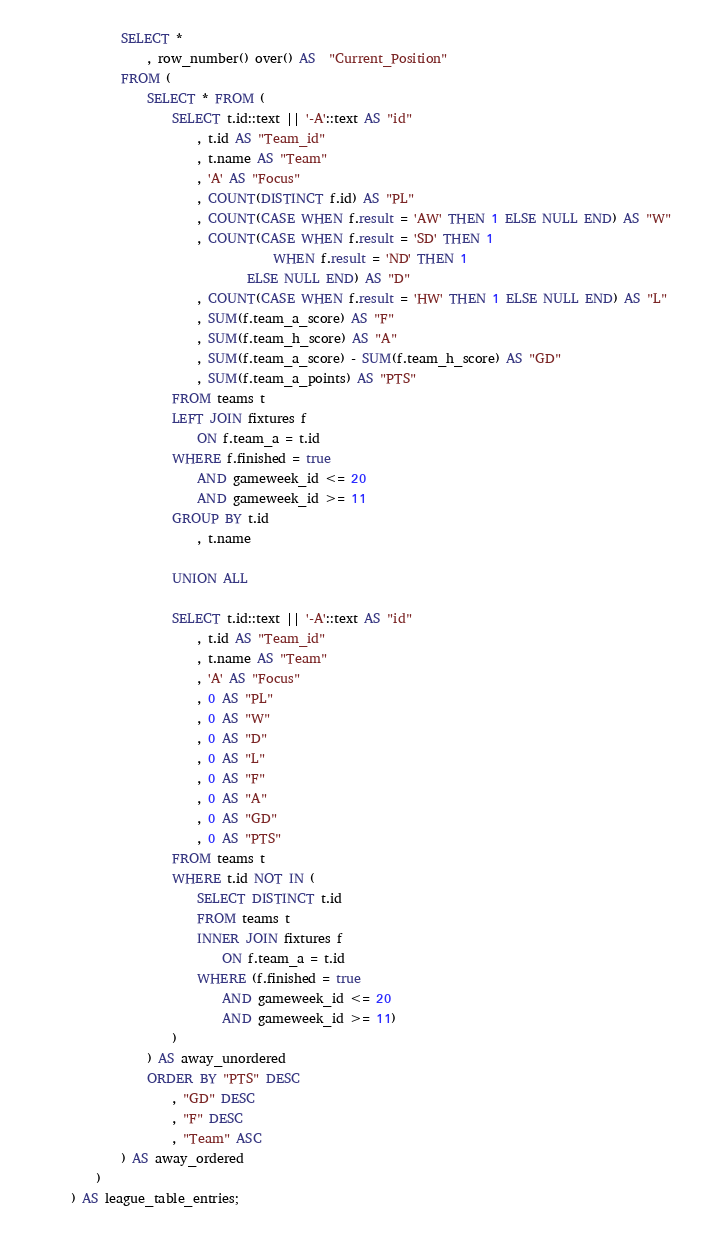<code> <loc_0><loc_0><loc_500><loc_500><_SQL_>		SELECT *
			, row_number() over() AS  "Current_Position"
		FROM (
			SELECT * FROM (
				SELECT t.id::text || '-A'::text AS "id"
					, t.id AS "Team_id"
					, t.name AS "Team"
					, 'A' AS "Focus"
					, COUNT(DISTINCT f.id) AS "PL"
					, COUNT(CASE WHEN f.result = 'AW' THEN 1 ELSE NULL END) AS "W"
					, COUNT(CASE WHEN f.result = 'SD' THEN 1 
								WHEN f.result = 'ND' THEN 1
							ELSE NULL END) AS "D"
					, COUNT(CASE WHEN f.result = 'HW' THEN 1 ELSE NULL END) AS "L"
					, SUM(f.team_a_score) AS "F"
					, SUM(f.team_h_score) AS "A"
					, SUM(f.team_a_score) - SUM(f.team_h_score) AS "GD"
					, SUM(f.team_a_points) AS "PTS"
				FROM teams t
				LEFT JOIN fixtures f
					ON f.team_a = t.id
				WHERE f.finished = true
					AND gameweek_id <= 20
					AND gameweek_id >= 11
				GROUP BY t.id
					, t.name

				UNION ALL

				SELECT t.id::text || '-A'::text AS "id"
					, t.id AS "Team_id"
					, t.name AS "Team"
					, 'A' AS "Focus"	
					, 0 AS "PL"
					, 0 AS "W"
					, 0 AS "D"
					, 0 AS "L"
					, 0 AS "F"
					, 0 AS "A"
					, 0 AS "GD"
					, 0 AS "PTS"
				FROM teams t
				WHERE t.id NOT IN (
					SELECT DISTINCT t.id
					FROM teams t
					INNER JOIN fixtures f
						ON f.team_a = t.id
					WHERE (f.finished = true
						AND gameweek_id <= 20
						AND gameweek_id >= 11)
				)
			) AS away_unordered
			ORDER BY "PTS" DESC
				, "GD" DESC
				, "F" DESC
				, "Team" ASC
		) AS away_ordered
	)
) AS league_table_entries;</code> 